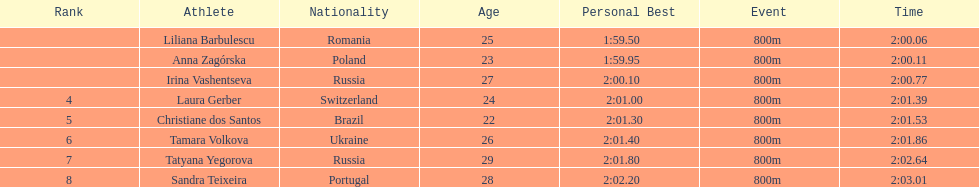What was anna zagorska's completion time? 2:00.11. 